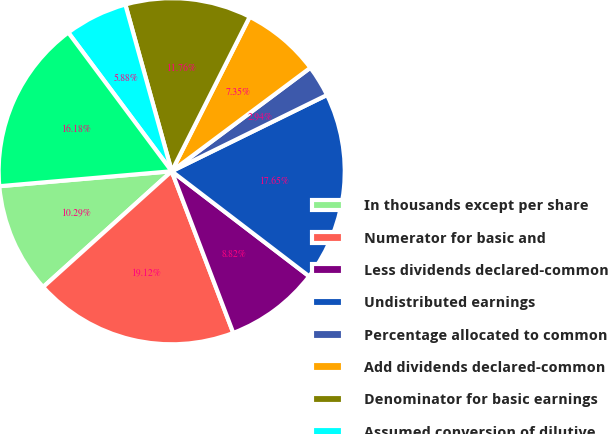Convert chart. <chart><loc_0><loc_0><loc_500><loc_500><pie_chart><fcel>In thousands except per share<fcel>Numerator for basic and<fcel>Less dividends declared-common<fcel>Undistributed earnings<fcel>Percentage allocated to common<fcel>Add dividends declared-common<fcel>Denominator for basic earnings<fcel>Assumed conversion of dilutive<fcel>Denominator for diluted<nl><fcel>10.29%<fcel>19.12%<fcel>8.82%<fcel>17.65%<fcel>2.94%<fcel>7.35%<fcel>11.76%<fcel>5.88%<fcel>16.18%<nl></chart> 